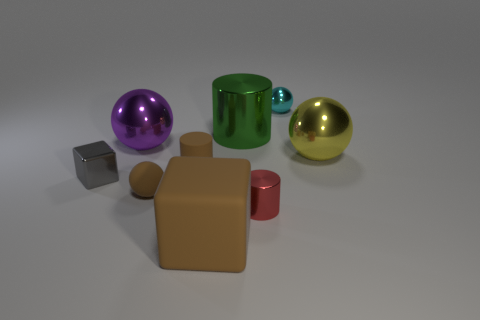Is there a tiny object that has the same color as the big block?
Give a very brief answer. Yes. Do the big thing in front of the yellow shiny thing and the small rubber cylinder have the same color?
Give a very brief answer. Yes. The large object that is the same color as the tiny matte ball is what shape?
Offer a terse response. Cube. Is the big rubber block the same color as the tiny matte ball?
Offer a terse response. Yes. There is a green object that is the same shape as the small red object; what is it made of?
Your response must be concise. Metal. There is a object that is both behind the brown rubber cylinder and on the left side of the big cube; what color is it?
Your response must be concise. Purple. Are there any big spheres that are to the right of the metallic ball that is left of the shiny object that is in front of the gray object?
Ensure brevity in your answer.  Yes. What number of things are large cyan cylinders or tiny brown rubber things?
Your response must be concise. 2. Is the cyan sphere made of the same material as the tiny cylinder that is on the left side of the small red metallic cylinder?
Make the answer very short. No. Are there any other things of the same color as the tiny rubber cylinder?
Make the answer very short. Yes. 